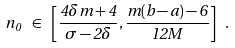<formula> <loc_0><loc_0><loc_500><loc_500>n _ { 0 } \ \in \ \left [ \frac { 4 \delta m + 4 } { \sigma - 2 \delta } , \frac { m ( b - a ) - 6 } { 1 2 M } \right ] \ .</formula> 